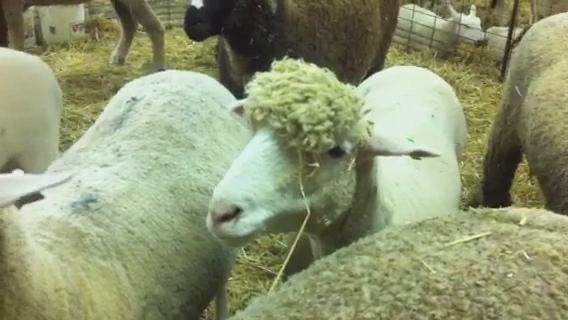Is the sheep looking at the camera?
Answer briefly. No. What is in front of the animals face?
Concise answer only. Straw. Is this a petting zoo?
Quick response, please. No. Are these sheep shorn?
Quick response, please. Yes. 